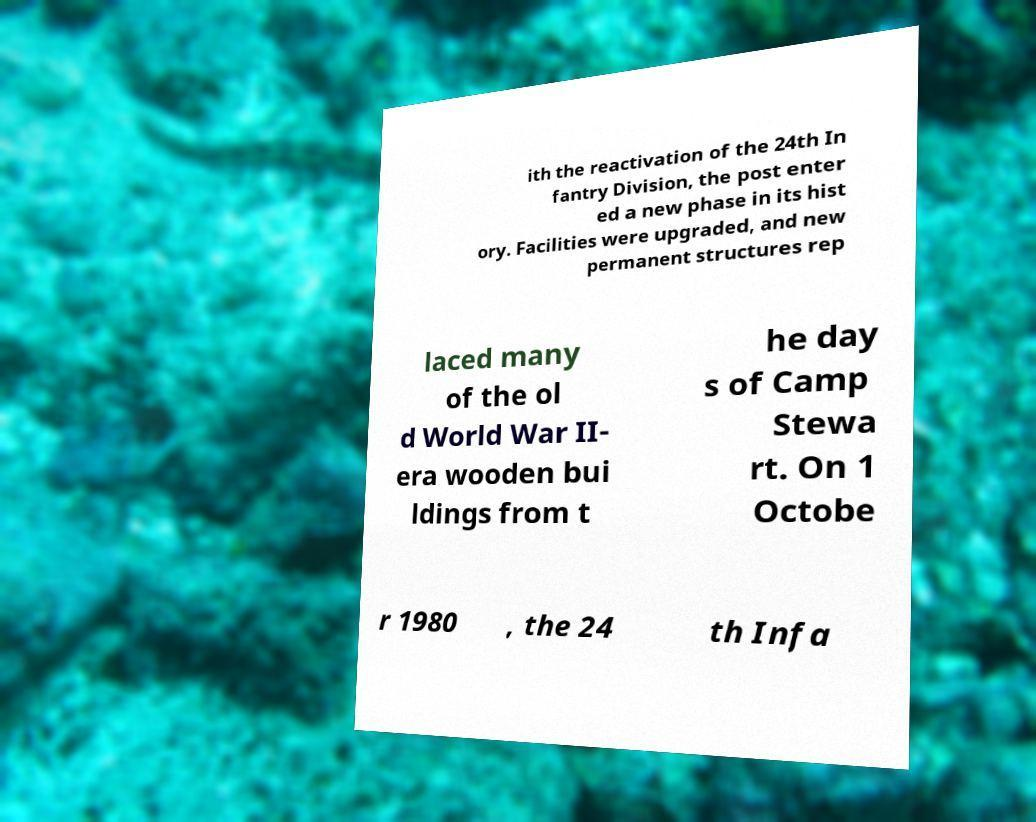There's text embedded in this image that I need extracted. Can you transcribe it verbatim? ith the reactivation of the 24th In fantry Division, the post enter ed a new phase in its hist ory. Facilities were upgraded, and new permanent structures rep laced many of the ol d World War II- era wooden bui ldings from t he day s of Camp Stewa rt. On 1 Octobe r 1980 , the 24 th Infa 